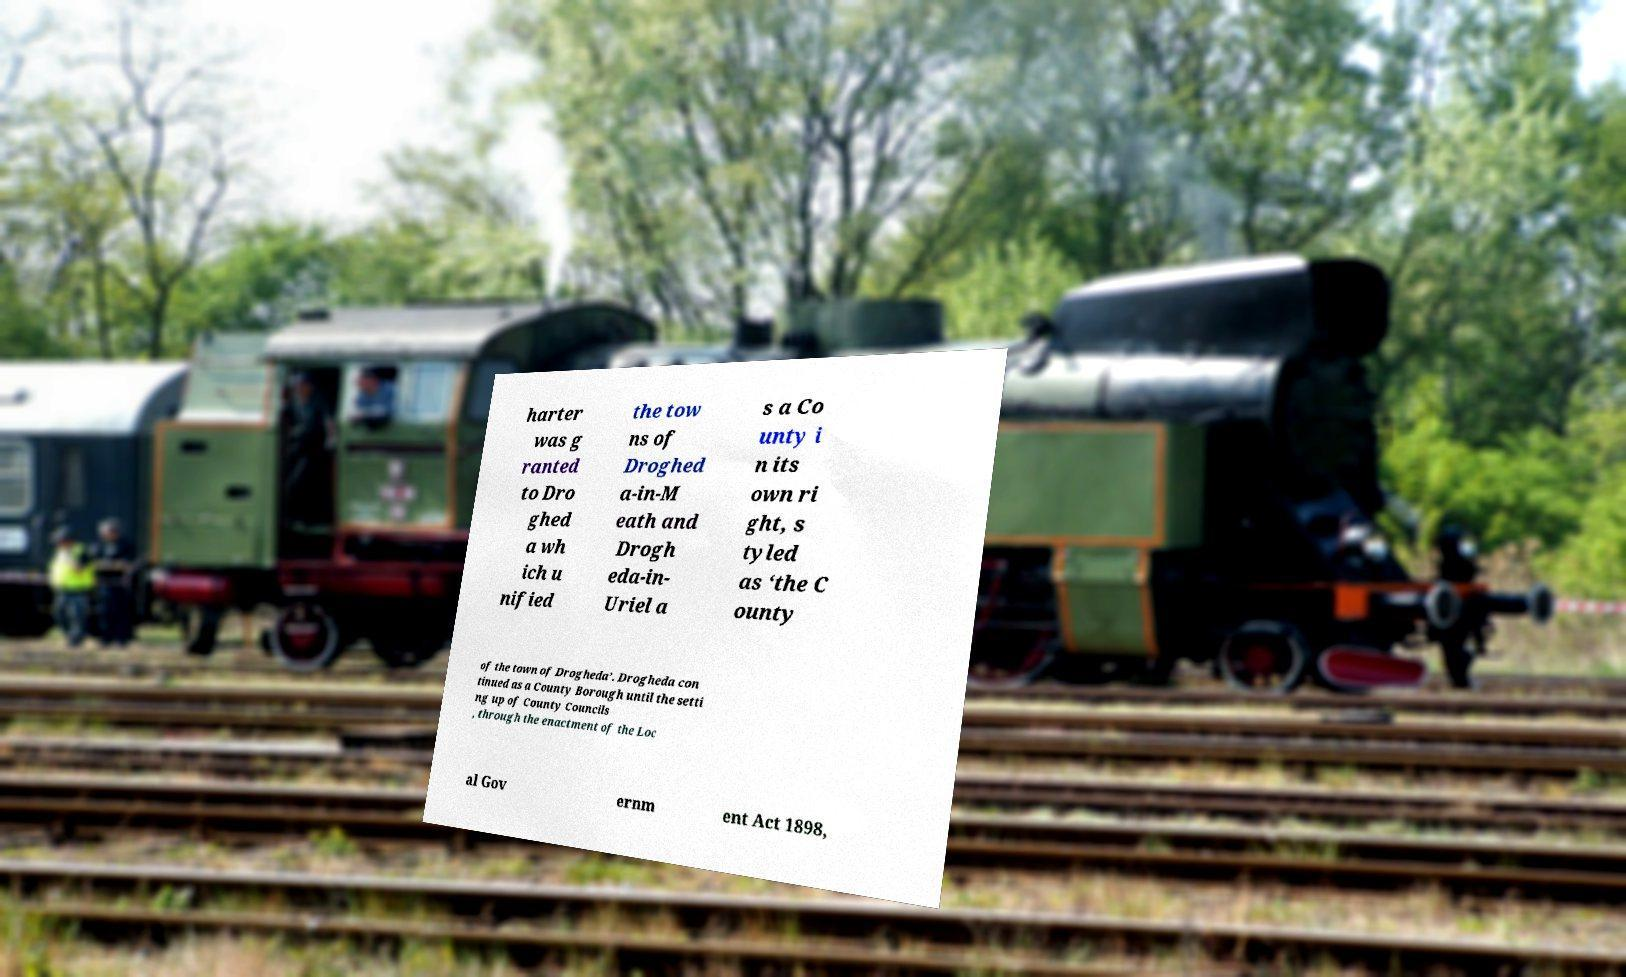What messages or text are displayed in this image? I need them in a readable, typed format. harter was g ranted to Dro ghed a wh ich u nified the tow ns of Droghed a-in-M eath and Drogh eda-in- Uriel a s a Co unty i n its own ri ght, s tyled as ‘the C ounty of the town of Drogheda’. Drogheda con tinued as a County Borough until the setti ng up of County Councils , through the enactment of the Loc al Gov ernm ent Act 1898, 